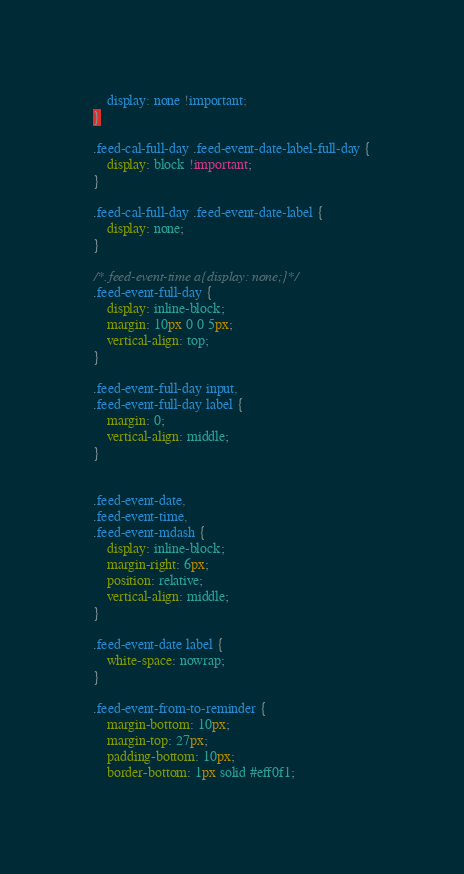<code> <loc_0><loc_0><loc_500><loc_500><_CSS_>	display: none !important;
}

.feed-cal-full-day .feed-event-date-label-full-day {
	display: block !important;
}

.feed-cal-full-day .feed-event-date-label {
	display: none;
}

/*.feed-event-time a{display: none;}*/
.feed-event-full-day {
	display: inline-block;
	margin: 10px 0 0 5px;
	vertical-align: top;
}

.feed-event-full-day input,
.feed-event-full-day label {
	margin: 0;
	vertical-align: middle;
}


.feed-event-date,
.feed-event-time,
.feed-event-mdash {
	display: inline-block;
	margin-right: 6px;
	position: relative;
	vertical-align: middle;
}

.feed-event-date label {
	white-space: nowrap;
}

.feed-event-from-to-reminder {
	margin-bottom: 10px;
	margin-top: 27px;
	padding-bottom: 10px;
	border-bottom: 1px solid #eff0f1;</code> 